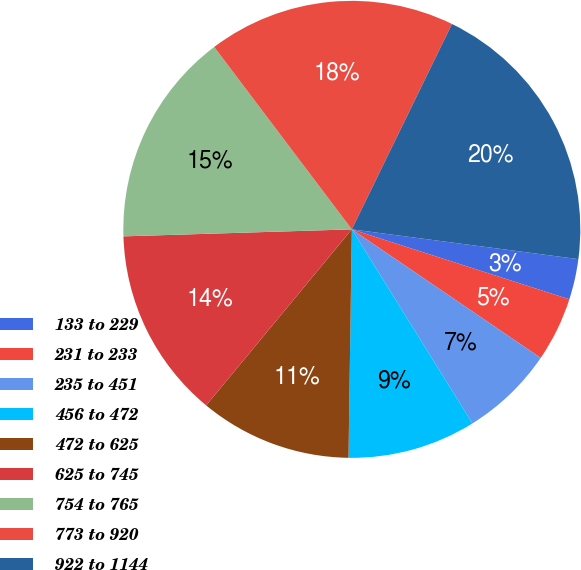Convert chart to OTSL. <chart><loc_0><loc_0><loc_500><loc_500><pie_chart><fcel>133 to 229<fcel>231 to 233<fcel>235 to 451<fcel>456 to 472<fcel>472 to 625<fcel>625 to 745<fcel>754 to 765<fcel>773 to 920<fcel>922 to 1144<nl><fcel>2.87%<fcel>4.56%<fcel>6.64%<fcel>9.08%<fcel>10.77%<fcel>13.51%<fcel>15.2%<fcel>17.51%<fcel>19.86%<nl></chart> 